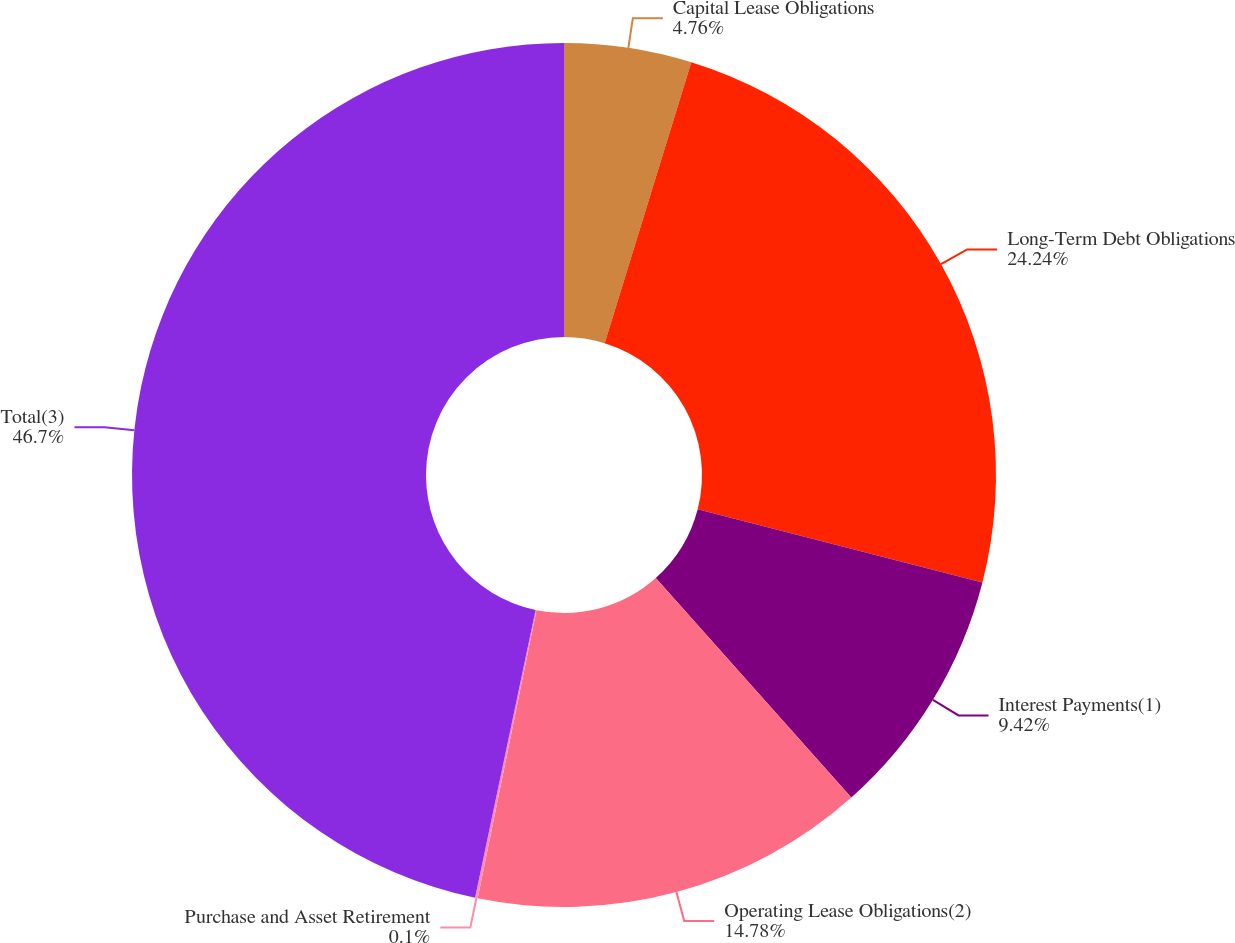Convert chart to OTSL. <chart><loc_0><loc_0><loc_500><loc_500><pie_chart><fcel>Capital Lease Obligations<fcel>Long-Term Debt Obligations<fcel>Interest Payments(1)<fcel>Operating Lease Obligations(2)<fcel>Purchase and Asset Retirement<fcel>Total(3)<nl><fcel>4.76%<fcel>24.24%<fcel>9.42%<fcel>14.78%<fcel>0.1%<fcel>46.7%<nl></chart> 